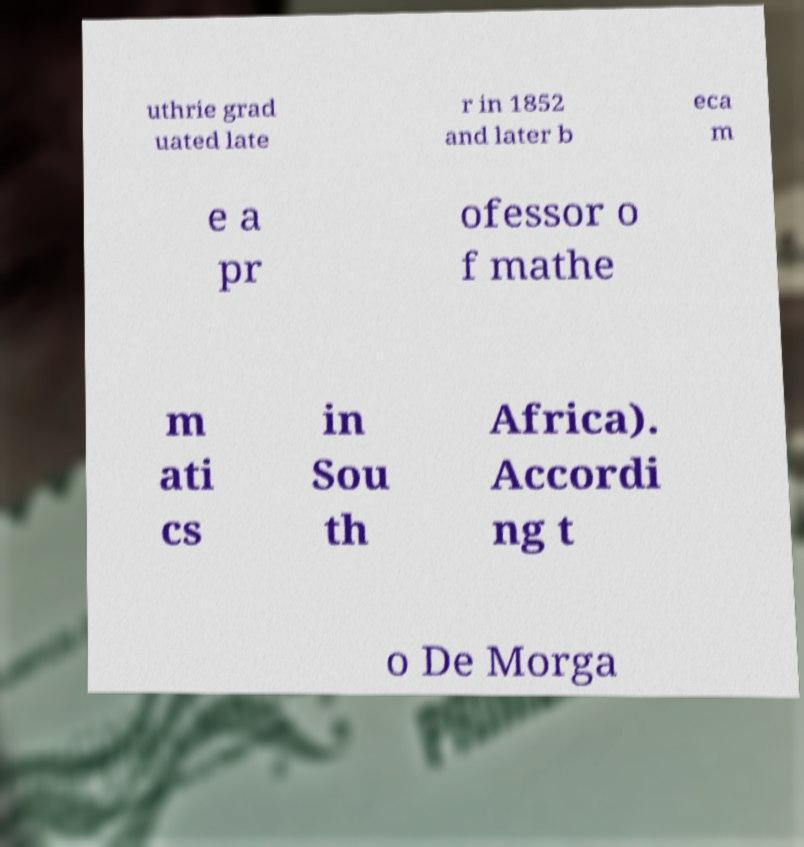Could you extract and type out the text from this image? uthrie grad uated late r in 1852 and later b eca m e a pr ofessor o f mathe m ati cs in Sou th Africa). Accordi ng t o De Morga 